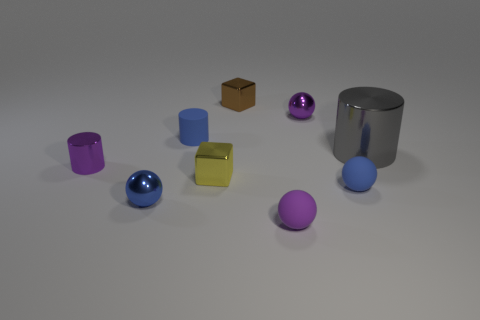Subtract all small purple metal balls. How many balls are left? 3 Add 1 brown metallic cylinders. How many objects exist? 10 Subtract all brown blocks. How many blocks are left? 1 Subtract 1 cylinders. How many cylinders are left? 2 Subtract all red spheres. How many yellow blocks are left? 1 Subtract all balls. How many objects are left? 5 Subtract all blue cylinders. Subtract all purple cubes. How many cylinders are left? 2 Subtract all small blue objects. Subtract all tiny blue cylinders. How many objects are left? 5 Add 7 large gray objects. How many large gray objects are left? 8 Add 3 small blue rubber balls. How many small blue rubber balls exist? 4 